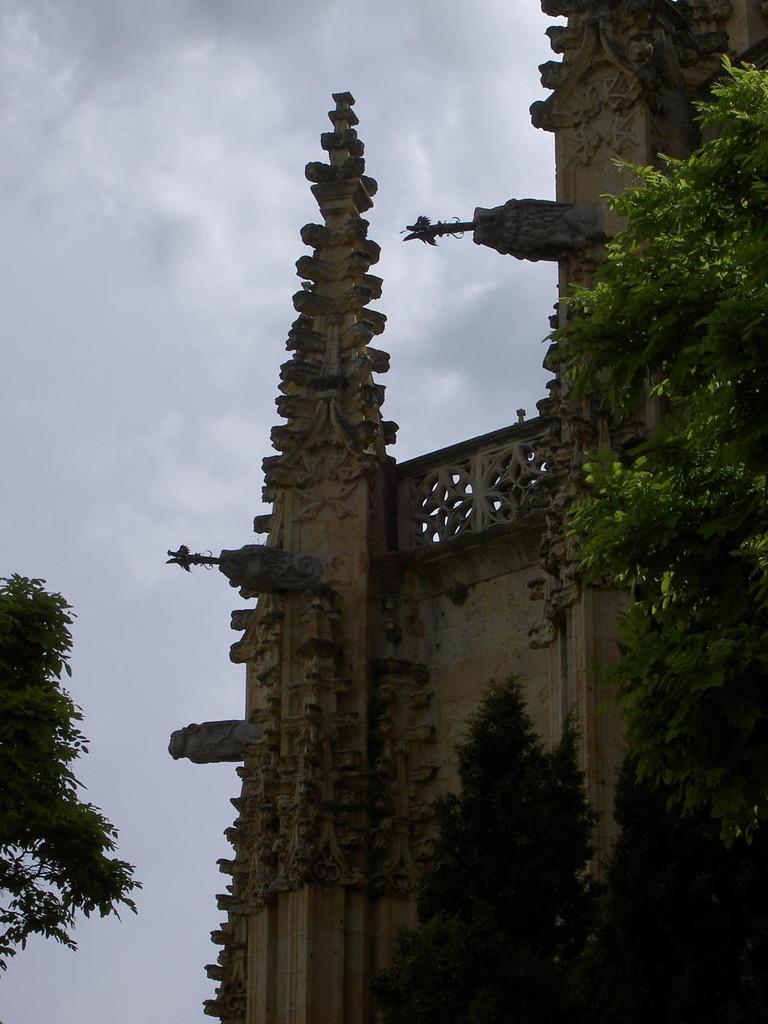Can you describe this image briefly? In this image I can see a building and few trees. The sky is in blue and white color. 